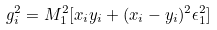<formula> <loc_0><loc_0><loc_500><loc_500>g _ { i } ^ { 2 } = M ^ { 2 } _ { 1 } [ x _ { i } y _ { i } + ( x _ { i } - y _ { i } ) ^ { 2 } \epsilon _ { 1 } ^ { 2 } ]</formula> 